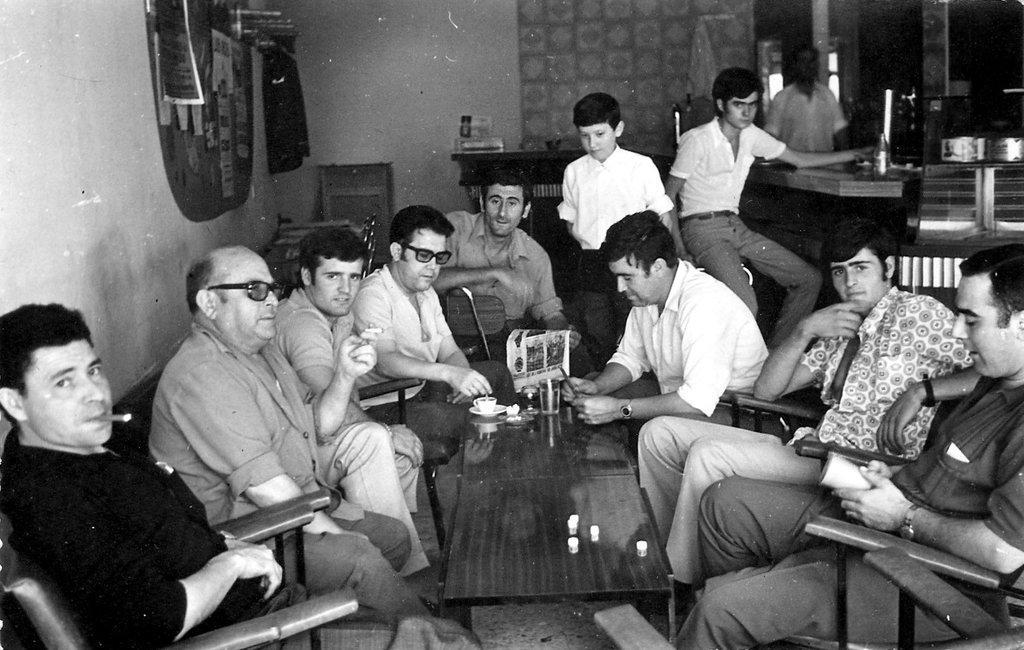Can you describe this image briefly? There are few people here sitting on the chair at the table. On the table there are glasses and a cup. On the right a person is standing. In the background there is a wall and posters on it. 